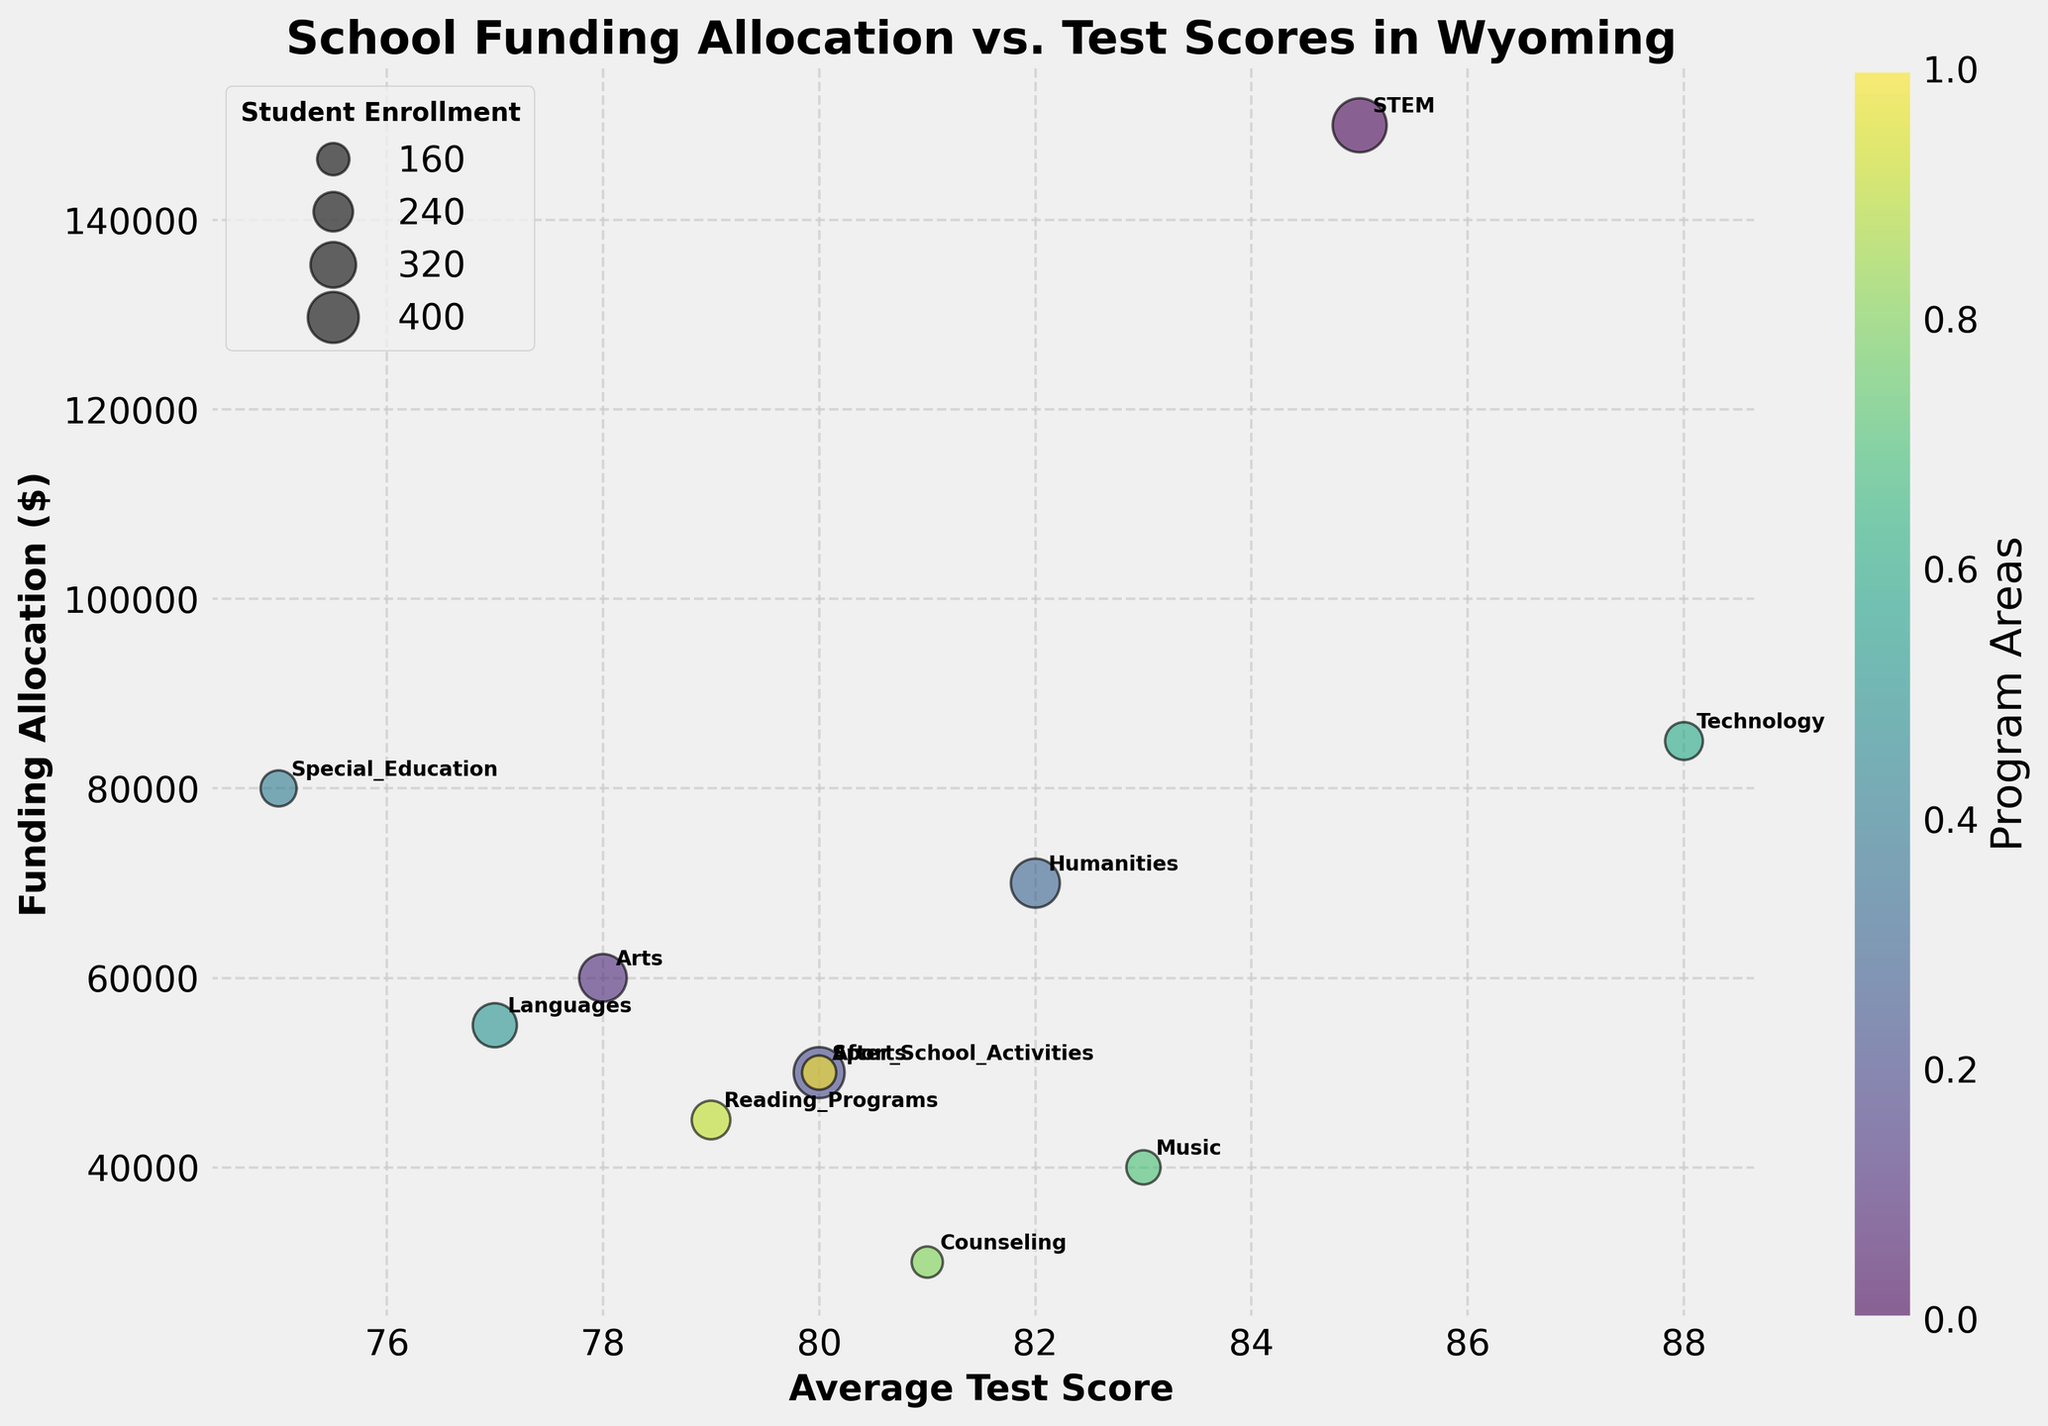What's the title of the figure? The title of the figure is prominently displayed at the top. It reads "School Funding Allocation vs. Test Scores in Wyoming".
Answer: School Funding Allocation vs. Test Scores in Wyoming What do the x-axis and y-axis represent? The x-axis represents the Average Test Score, and the y-axis represents the Funding Allocation in dollars. These labels are provided along each axis in the figure.
Answer: x-axis: Average Test Score, y-axis: Funding Allocation Which program has the highest average test score? By looking at the position of the bubbles along the x-axis, the Technology program has the highest average test score, being furthest to the right.
Answer: Technology How many programs have a funding allocation of $50,000? To find this, we look at the y-axis and count the bubbles at the $50,000 mark. The Sports and After School Activities programs are at this level.
Answer: 2 Which program has the largest student enrollment, and how is this determined? Student enrollment is indicated by the size of the bubble. The largest bubble represents the program with the largest enrollment, which is STEM.
Answer: STEM What's the relationship between funding allocation and test scores for Special Education? For the Special Education program, its funding allocation is $80,000, and the average test score is 75.
Answer: Funding Allocation: $80,000, Average Test Score: 75 Compare the test scores of the Music and Humanities programs. Which one is higher? The Music program has an average test score of 83, while the Humanities program has an average test score of 82. By comparing these values, Music has a higher test score.
Answer: Music If we rank the programs based on funding allocation, which program is in the middle? To find the median program by funding allocation, list all programs sorted by funding. The sixth program in the list is the median:
1. Counseling - $30,000
2. Reading Programs - $45,000
3. Music - $40,000
4. Arts - $60,000
5. Languages - $55,000
6. After School Activities - $50,000
Sports and After School Activities have the same funding, so After School Activities (or Sports) can be considered the median.
Answer: After School Activities (or Sports) Which program with an above-average test score has the lowest funding allocation? By observing the bubbles to the right of the average test score line around 80 and identifying the one lowest on the y-axis, the Music program has an above-average test score (83) and the lowest funding allocation ($40,000) among the ones to the right of 80.
Answer: Music What is the approximate range of student enrollment among all programs? The smallest bubble represents the lowest enrollment (Counseling with 150 students), and the largest bubble represents the highest enrollment (STEM with 450 students). The range is 450 - 150.
Answer: 300ensions 